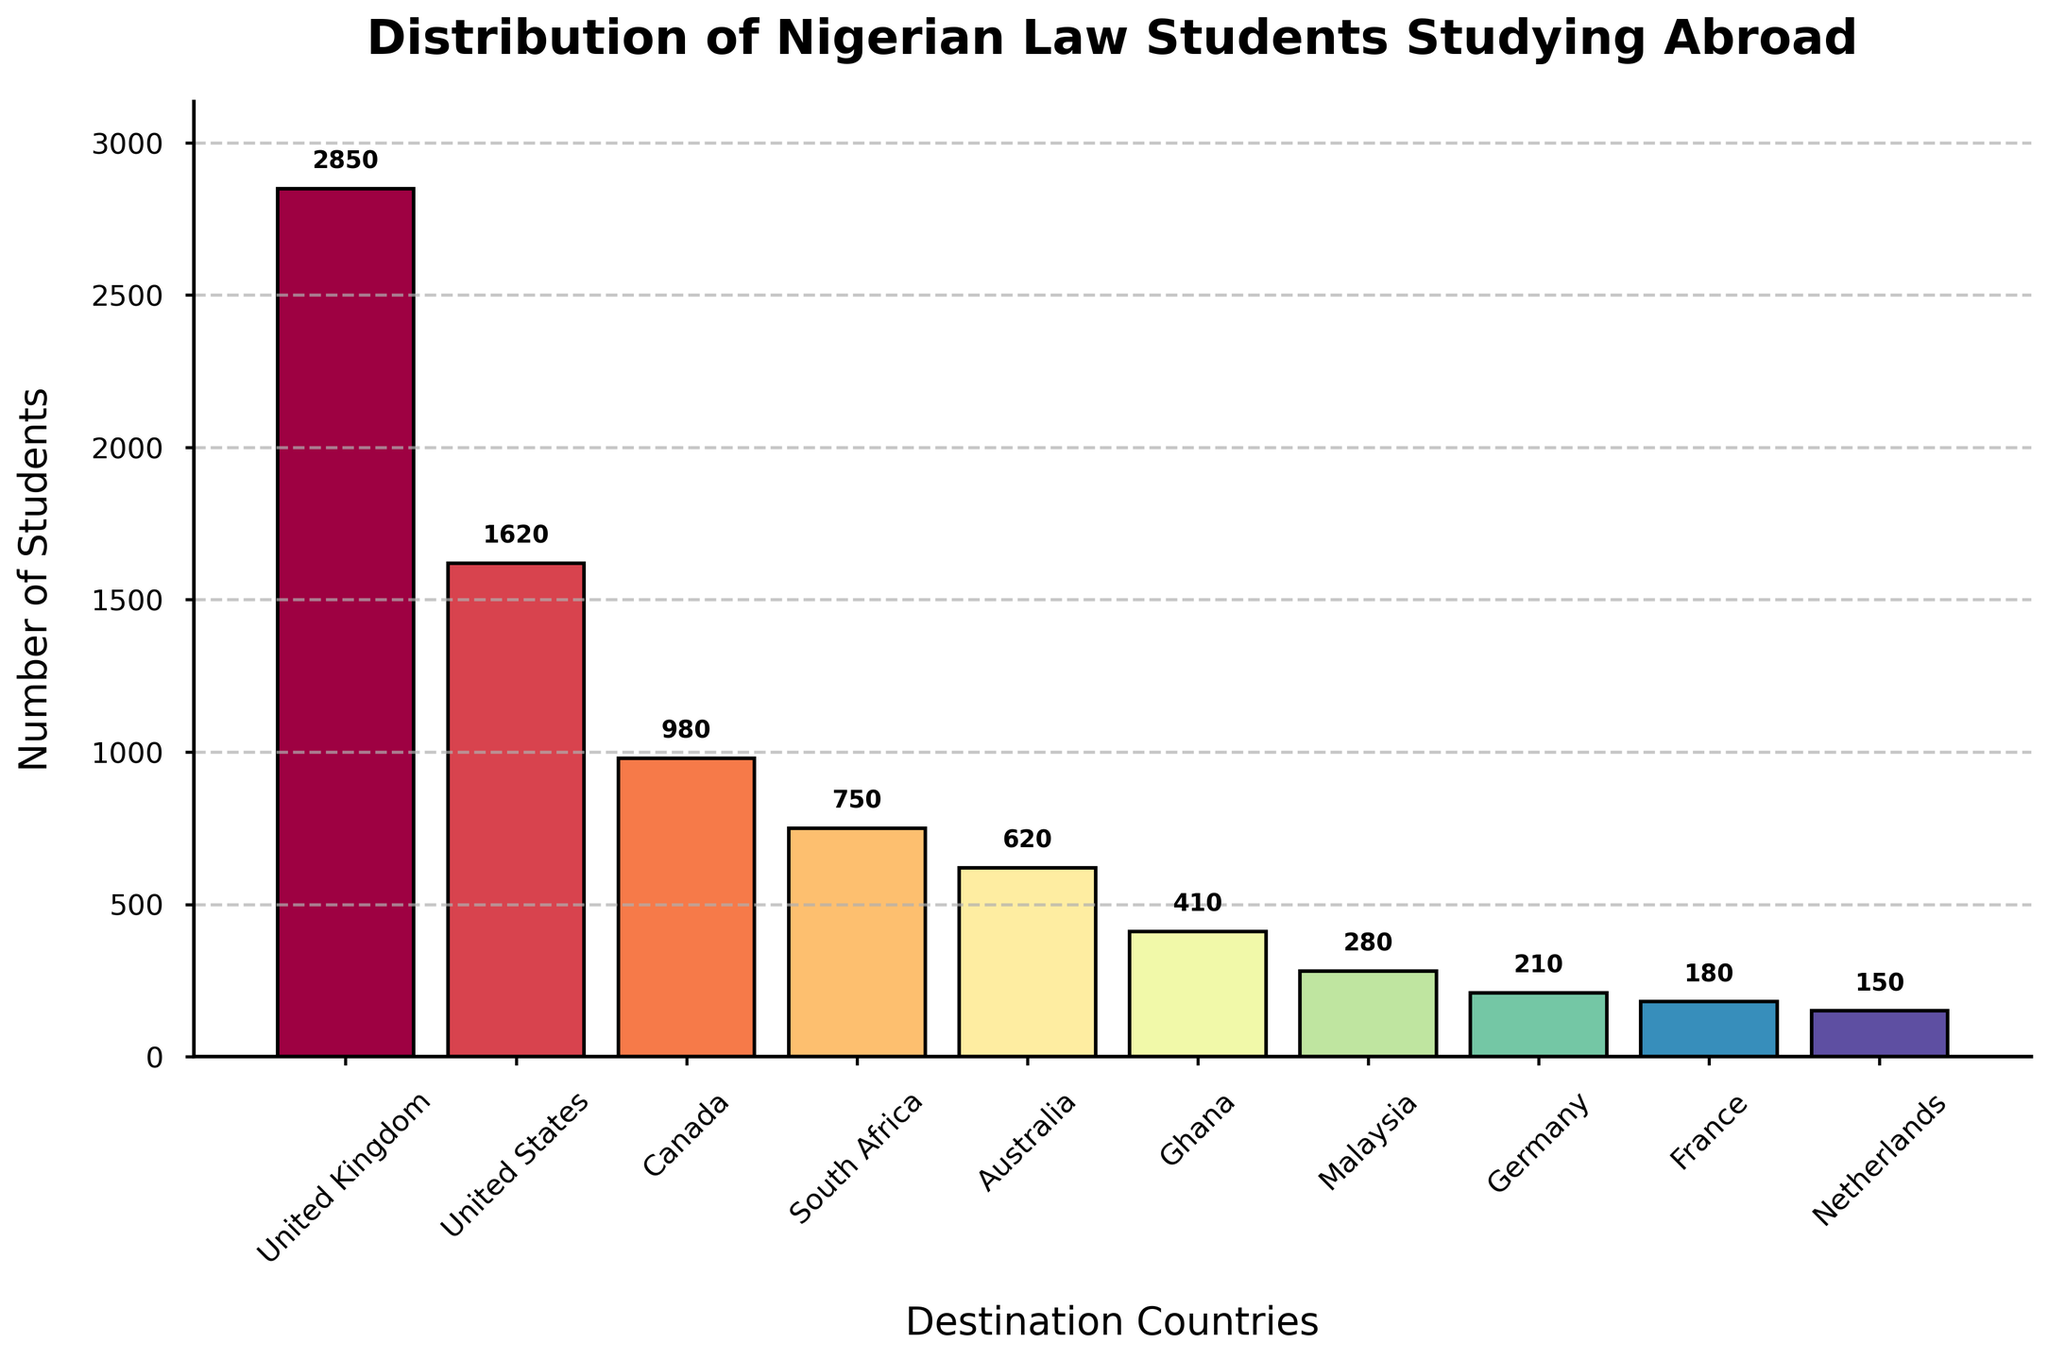Which country hosts the highest number of Nigerian law students? Look at the highest bar in the bar chart, which represents the United Kingdom with 2850 students.
Answer: United Kingdom Which country has fewer Nigerian law students, South Africa or Canada? Compare the bars representing South Africa (750 students) and Canada (980 students), and see that South Africa's bar is shorter.
Answer: South Africa What is the total number of Nigerian law students in the United Kingdom and the United States combined? Add the numbers of students in the United Kingdom (2850) and the United States (1620): 2850 + 1620.
Answer: 4470 How many more Nigerian law students are there in the United Kingdom compared to France? Subtract the number of students in France (180) from the number of students in the United Kingdom (2850): 2850 - 180.
Answer: 2670 What is the average number of Nigerian law students studying in South Africa, Australia, and Ghana? Add the numbers of students in South Africa (750), Australia (620), and Ghana (410), then divide by the number of countries (3): (750 + 620 + 410)/3.
Answer: 593.33 Which country has the smallest number of Nigerian law students? Look at the shortest bar in the chart, which represents the Netherlands with 150 students.
Answer: Netherlands Are there more Nigerian law students in Canada or Australia, and by how much? Compare the bars representing Canada (980 students) and Australia (620 students), then subtract the smaller number from the larger: 980 - 620.
Answer: Canada, by 360 What is the total number of Nigerian law students studying in the top three destination countries? Add the numbers of students in the United Kingdom (2850), United States (1620), and Canada (980): 2850 + 1620 + 980.
Answer: 5450 How does the population of Nigerian law students in Malaysia compare to that in Germany? Compare the bars representing Malaysia (280 students) and Germany (210 students); Malaysia has more students.
Answer: Malaysia Which two countries have a combined total of 390 Nigerian law students? Find which countries' bars add up to 390, which are Germany (210) and France (180): 210 + 180.
Answer: Germany and France 